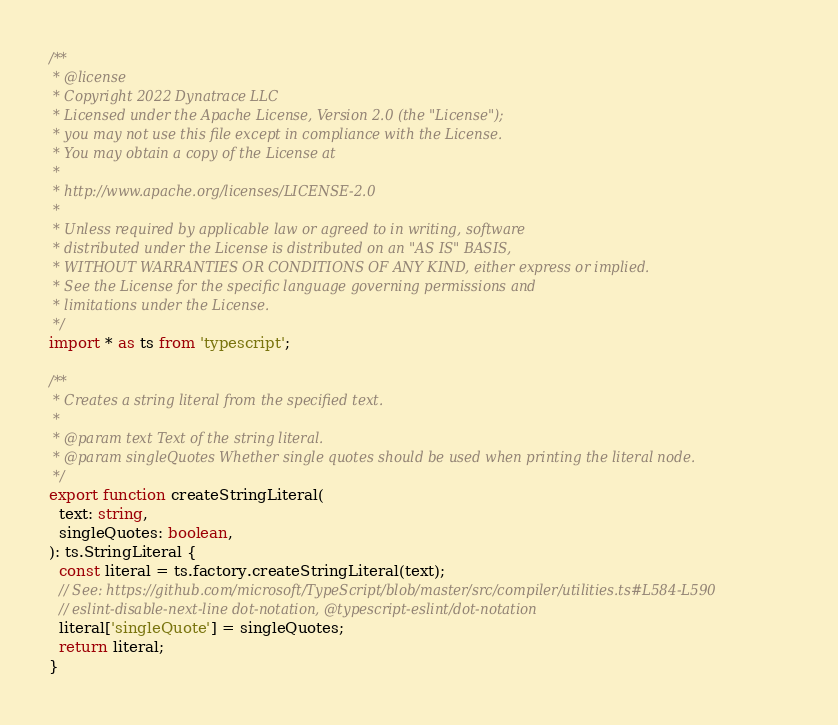<code> <loc_0><loc_0><loc_500><loc_500><_TypeScript_>/**
 * @license
 * Copyright 2022 Dynatrace LLC
 * Licensed under the Apache License, Version 2.0 (the "License");
 * you may not use this file except in compliance with the License.
 * You may obtain a copy of the License at
 *
 * http://www.apache.org/licenses/LICENSE-2.0
 *
 * Unless required by applicable law or agreed to in writing, software
 * distributed under the License is distributed on an "AS IS" BASIS,
 * WITHOUT WARRANTIES OR CONDITIONS OF ANY KIND, either express or implied.
 * See the License for the specific language governing permissions and
 * limitations under the License.
 */
import * as ts from 'typescript';

/**
 * Creates a string literal from the specified text.
 *
 * @param text Text of the string literal.
 * @param singleQuotes Whether single quotes should be used when printing the literal node.
 */
export function createStringLiteral(
  text: string,
  singleQuotes: boolean,
): ts.StringLiteral {
  const literal = ts.factory.createStringLiteral(text);
  // See: https://github.com/microsoft/TypeScript/blob/master/src/compiler/utilities.ts#L584-L590
  // eslint-disable-next-line dot-notation, @typescript-eslint/dot-notation
  literal['singleQuote'] = singleQuotes;
  return literal;
}
</code> 